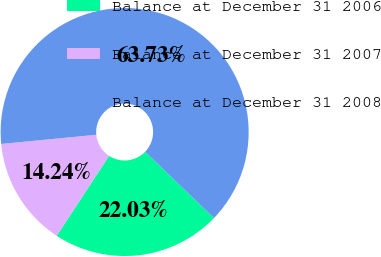<chart> <loc_0><loc_0><loc_500><loc_500><pie_chart><fcel>Balance at December 31 2006<fcel>Balance at December 31 2007<fcel>Balance at December 31 2008<nl><fcel>22.03%<fcel>14.24%<fcel>63.73%<nl></chart> 